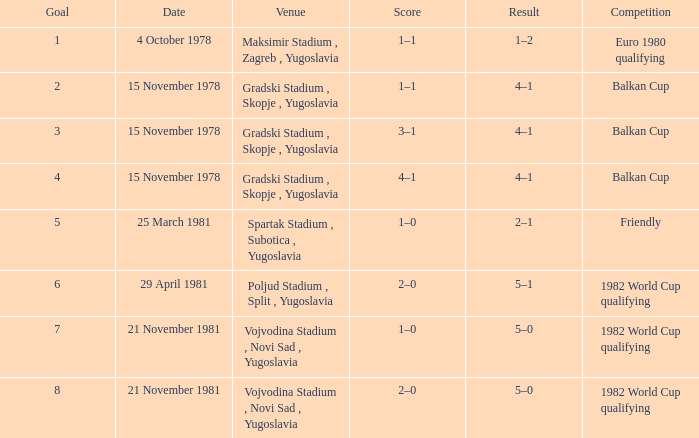What is the Result for Goal 3? 4–1. 